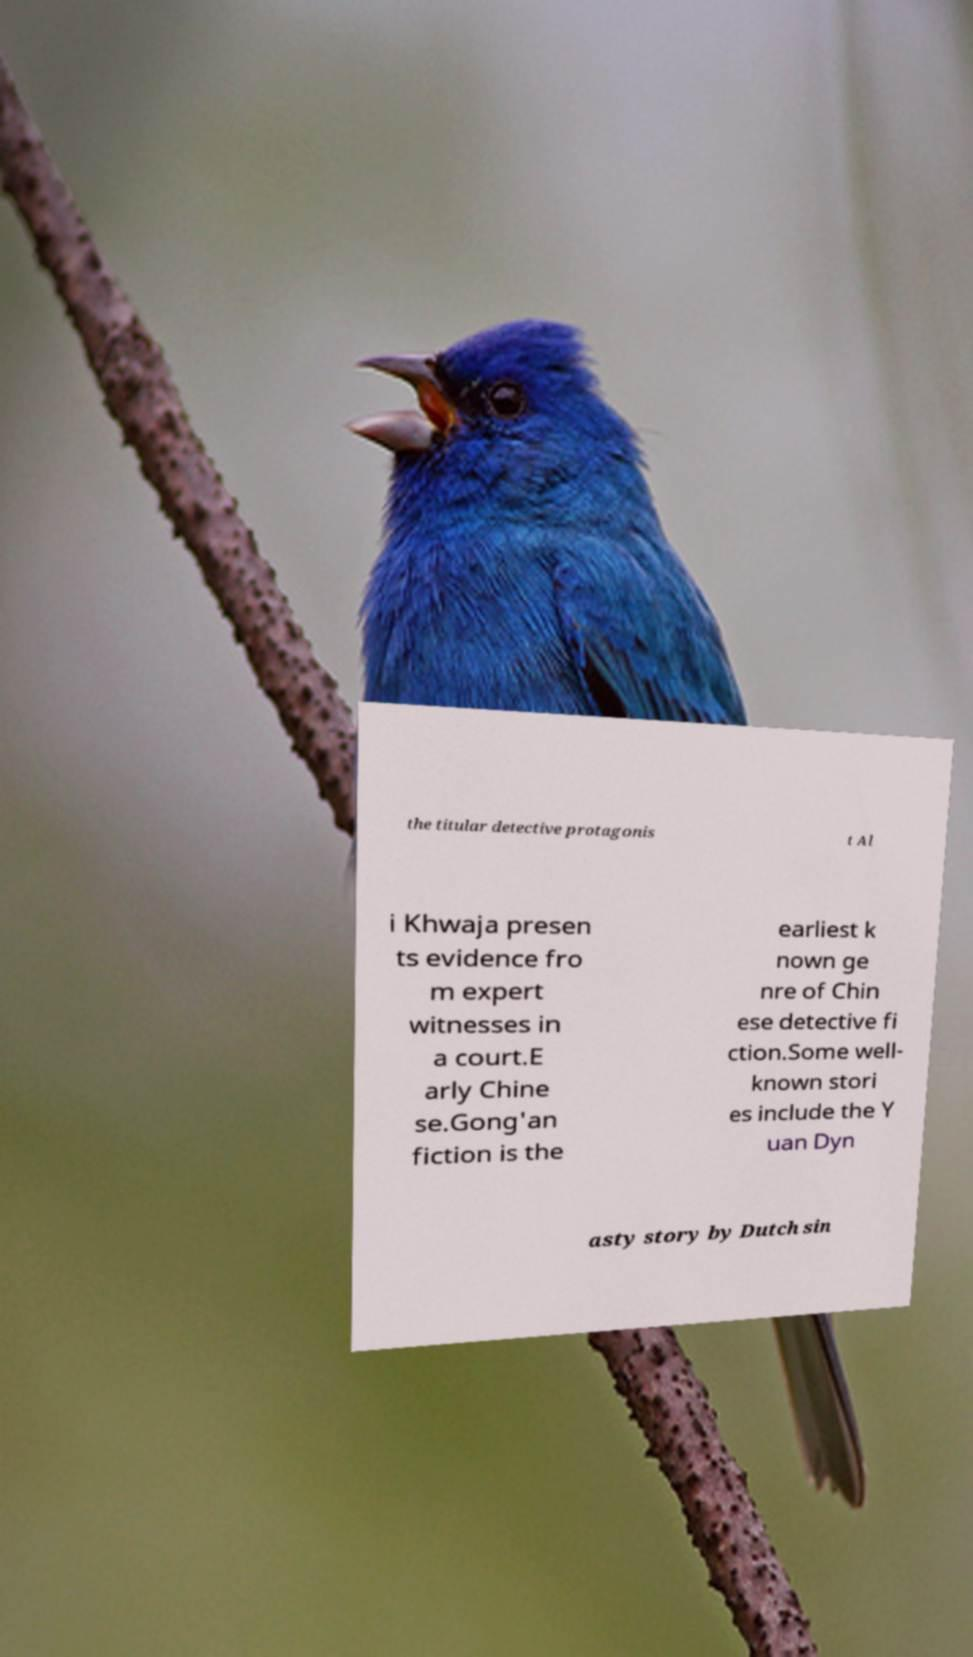Could you extract and type out the text from this image? the titular detective protagonis t Al i Khwaja presen ts evidence fro m expert witnesses in a court.E arly Chine se.Gong'an fiction is the earliest k nown ge nre of Chin ese detective fi ction.Some well- known stori es include the Y uan Dyn asty story by Dutch sin 